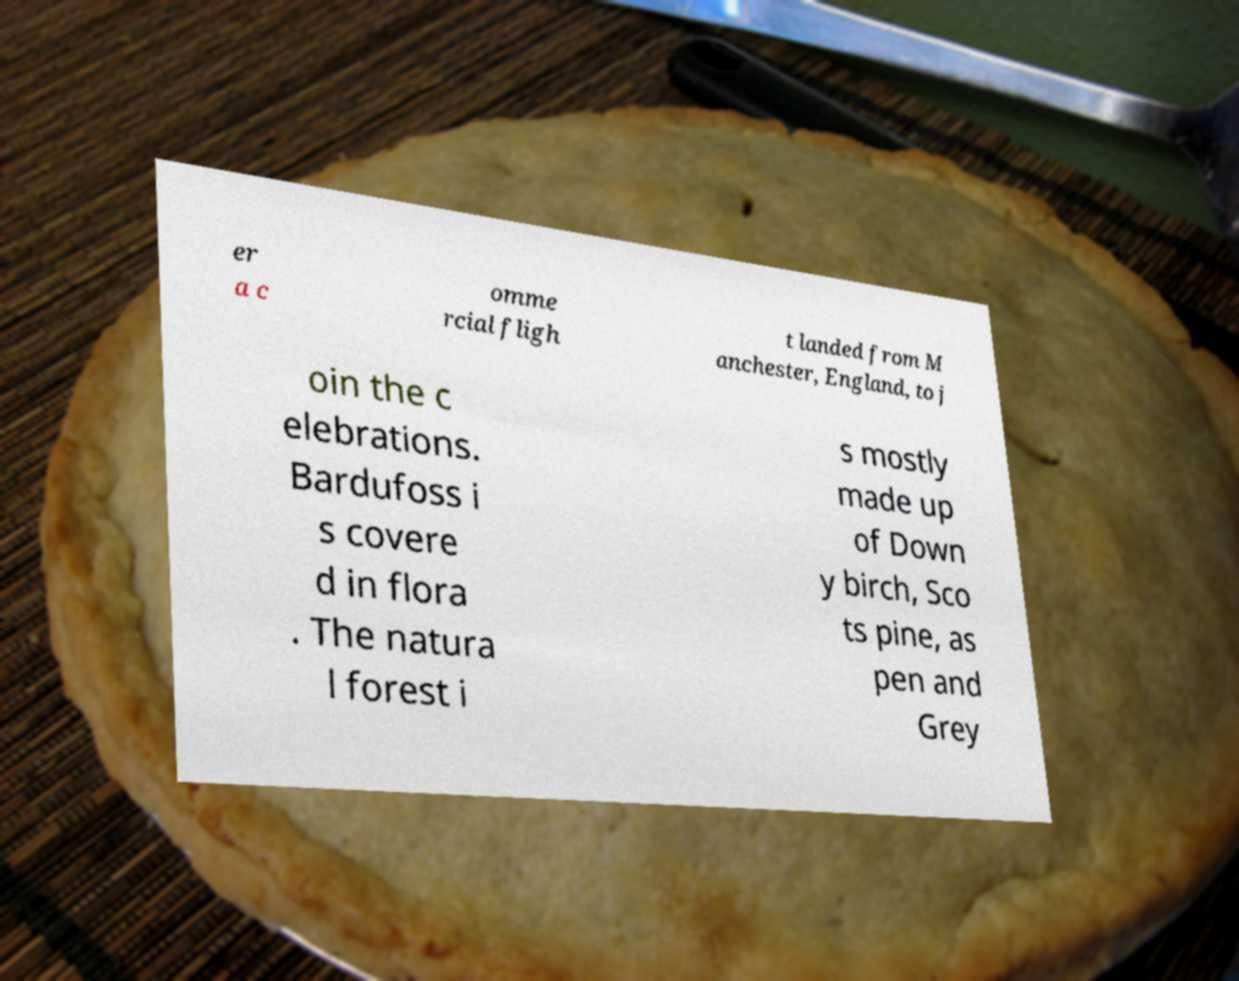Please identify and transcribe the text found in this image. er a c omme rcial fligh t landed from M anchester, England, to j oin the c elebrations. Bardufoss i s covere d in flora . The natura l forest i s mostly made up of Down y birch, Sco ts pine, as pen and Grey 